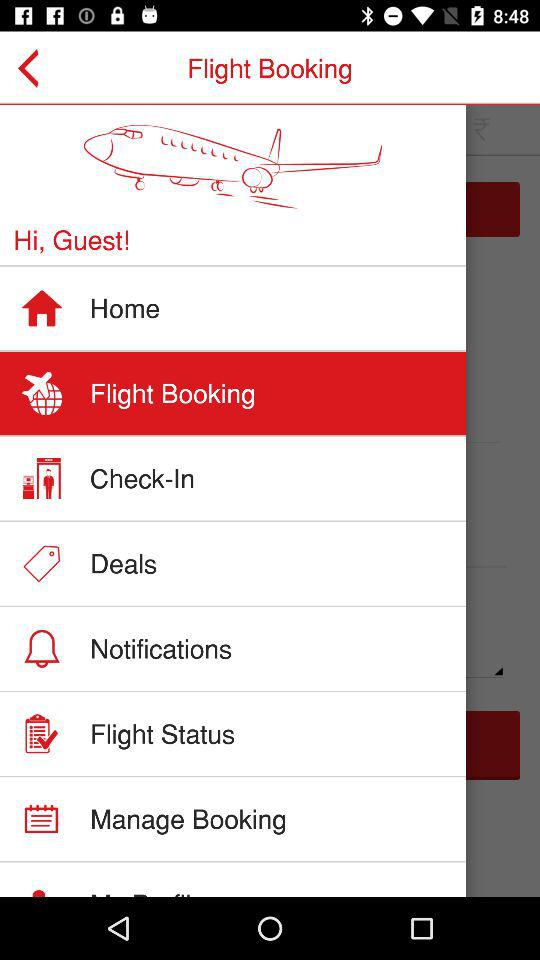When is check-in required?
When the provided information is insufficient, respond with <no answer>. <no answer> 